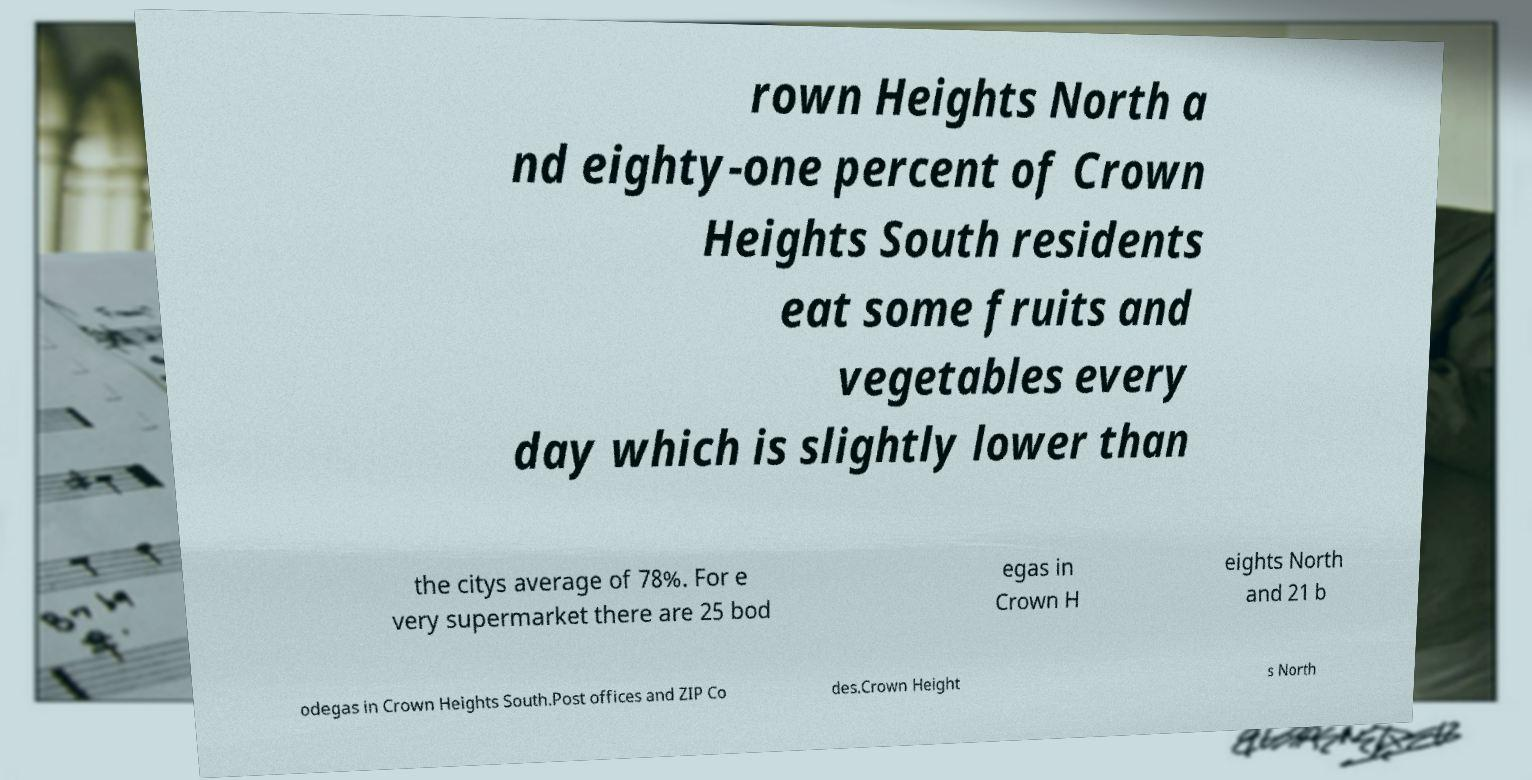Could you extract and type out the text from this image? rown Heights North a nd eighty-one percent of Crown Heights South residents eat some fruits and vegetables every day which is slightly lower than the citys average of 78%. For e very supermarket there are 25 bod egas in Crown H eights North and 21 b odegas in Crown Heights South.Post offices and ZIP Co des.Crown Height s North 